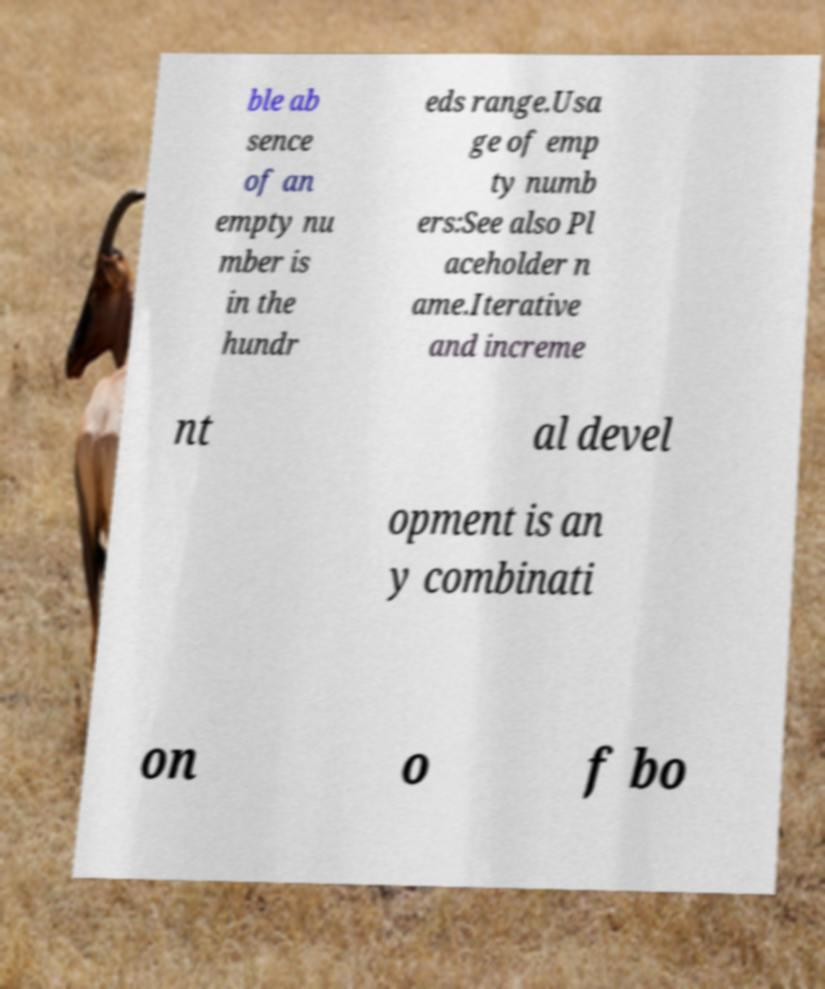Please identify and transcribe the text found in this image. ble ab sence of an empty nu mber is in the hundr eds range.Usa ge of emp ty numb ers:See also Pl aceholder n ame.Iterative and increme nt al devel opment is an y combinati on o f bo 